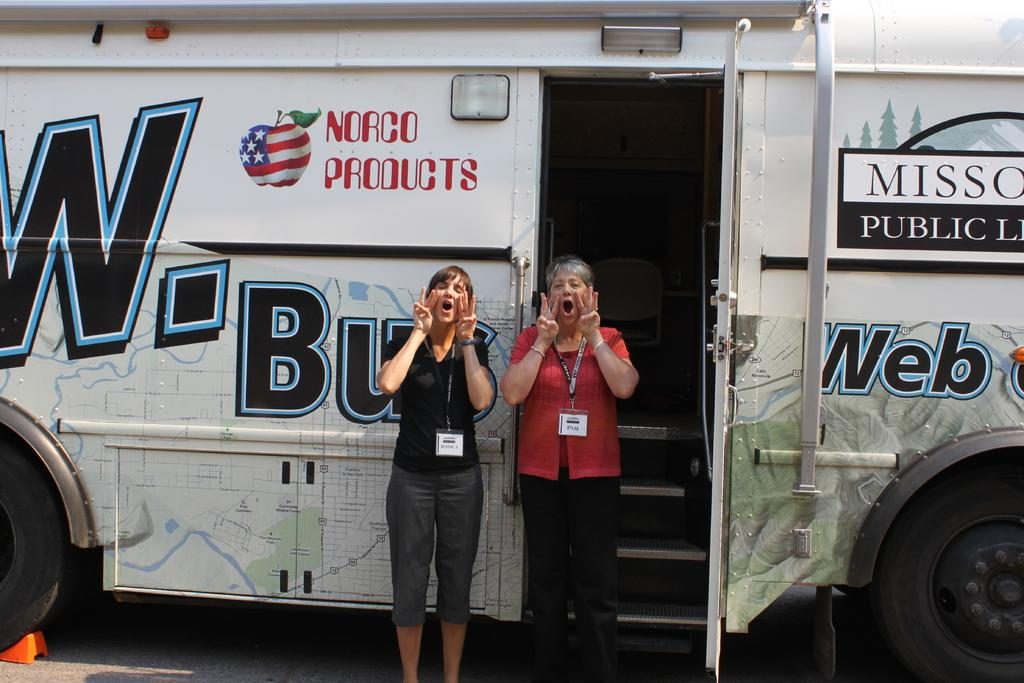How many people are present in the image? There are two people in the image. What are the two people doing? The two people are shouting. What can be seen on the road in the image? There is a bus on the road in the image. What type of care can be seen in the image? There is no care present in the image. What is the current situation of the two people in the image? The provided facts do not give information about the current situation of the two people, only their actions (shouting). 